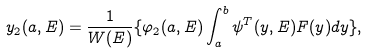Convert formula to latex. <formula><loc_0><loc_0><loc_500><loc_500>y _ { 2 } ( a , E ) = \frac { 1 } { W ( E ) } \{ \varphi _ { 2 } ( a , E ) \int ^ { b } _ { a } \psi ^ { T } ( y , E ) F ( y ) d y \} ,</formula> 